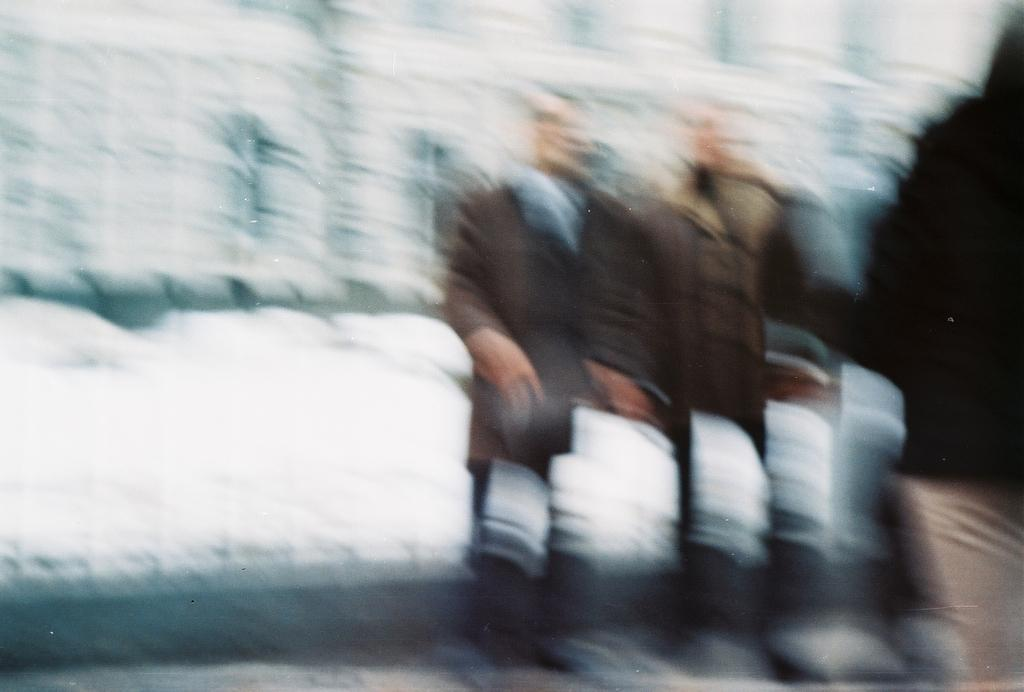How many people are in the image? There are people in the image, but the exact number is not specified. What type of weather is depicted in the image? There is snow visible in the image, which suggests a cold or wintry weather. What type of twist can be seen in the image? There is no twist present in the image. What type of skirt is worn by the people in the image? The provided facts do not mention any clothing details, including the presence of a skirt. 